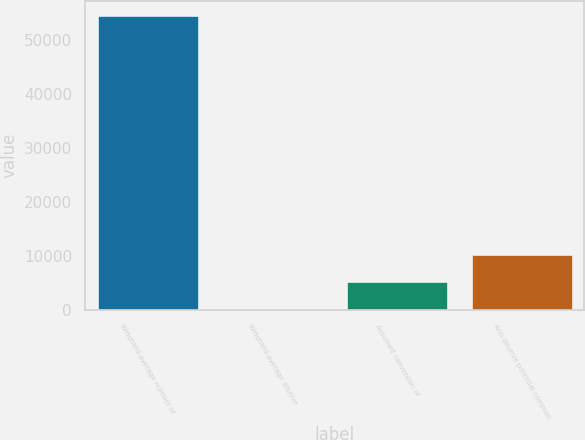Convert chart to OTSL. <chart><loc_0><loc_0><loc_500><loc_500><bar_chart><fcel>Weighted-average number of<fcel>Weighted-average dilutive<fcel>Assumed conversion of<fcel>Anti-dilutive potential common<nl><fcel>54473.5<fcel>238<fcel>5220.5<fcel>10203<nl></chart> 